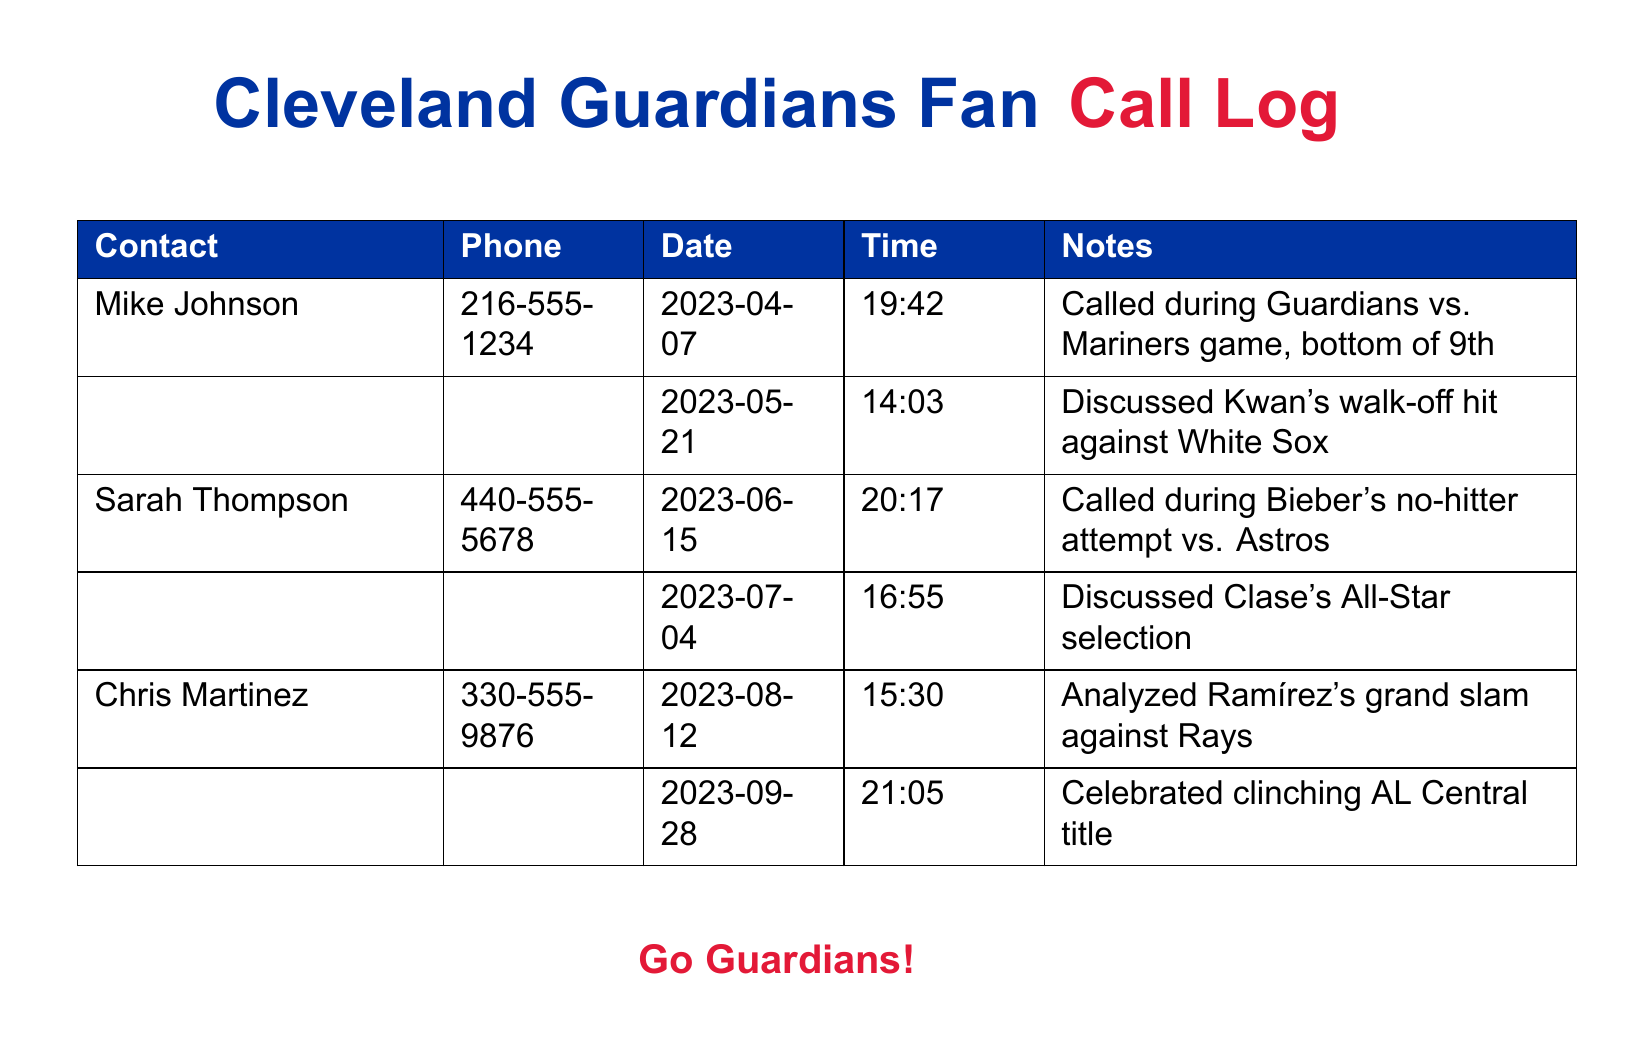What date did Mike Johnson call during the game? Mike Johnson called on April 7, 2023, during the Guardians vs. Mariners game.
Answer: April 7, 2023 Who discussed Kwan's walk-off hit? The call regarding Kwan's walk-off hit against the White Sox was between the user and Mike Johnson.
Answer: Mike Johnson What time did Chris Martinez call on September 28, 2023? Chris Martinez's call on September 28, 2023, occurred at 21:05.
Answer: 21:05 How many calls are listed for Sarah Thompson? There are two entries for calls made to Sarah Thompson, both listed with specific notes.
Answer: 2 What event did Mike Johnson call during on April 7, 2023? The call was made during the bottom of the 9th in the Guardians vs. Mariners game.
Answer: Bottom of 9th Which player’s All-Star selection was discussed on July 4, 2023? The discussion on July 4 was about Clase's All-Star selection.
Answer: Clase How many total calls occurred during game moments listed in the document? There are four calls mentioned that occurred during crucial game moments.
Answer: 4 Who analyzed Ramírez's grand slam against the Rays? The call analyzing Ramírez's grand slam was made by Chris Martinez.
Answer: Chris Martinez 